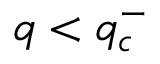<formula> <loc_0><loc_0><loc_500><loc_500>q < q _ { c } ^ { - }</formula> 